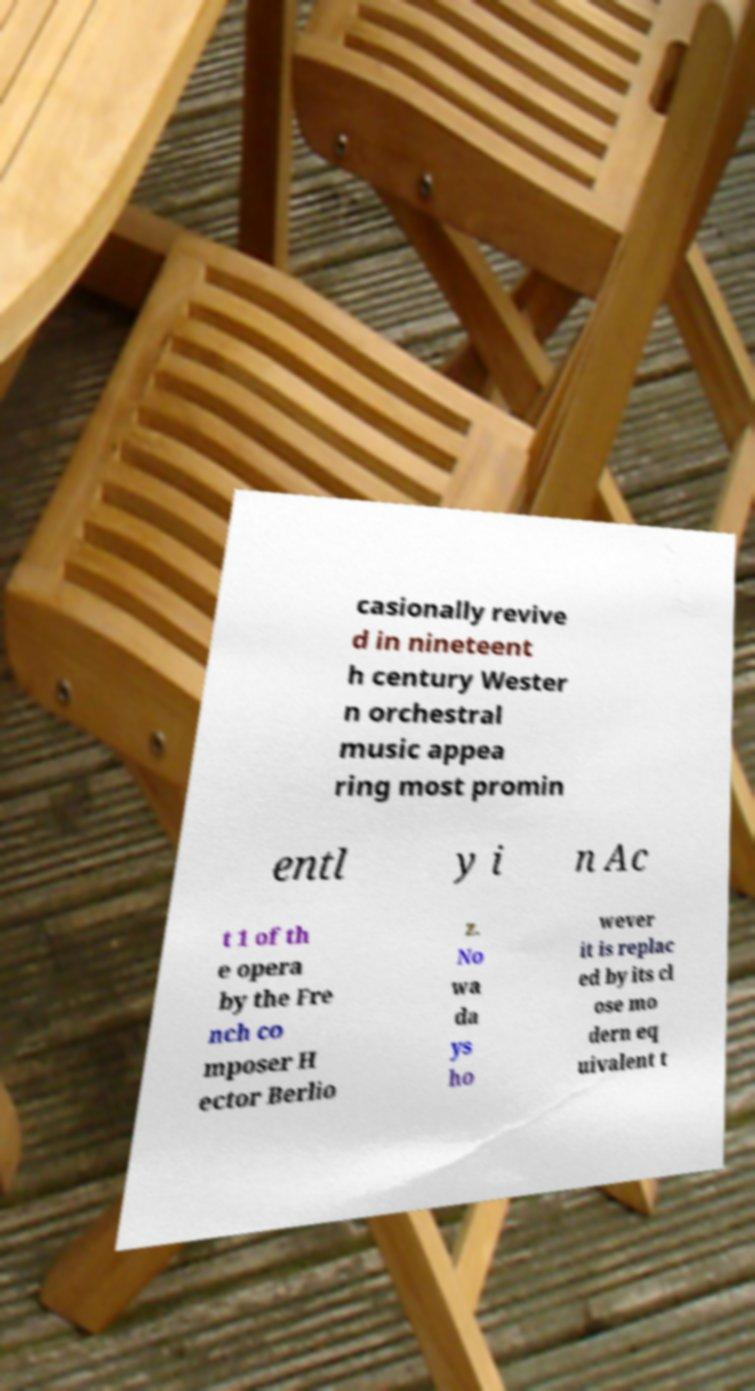There's text embedded in this image that I need extracted. Can you transcribe it verbatim? casionally revive d in nineteent h century Wester n orchestral music appea ring most promin entl y i n Ac t 1 of th e opera by the Fre nch co mposer H ector Berlio z. No wa da ys ho wever it is replac ed by its cl ose mo dern eq uivalent t 